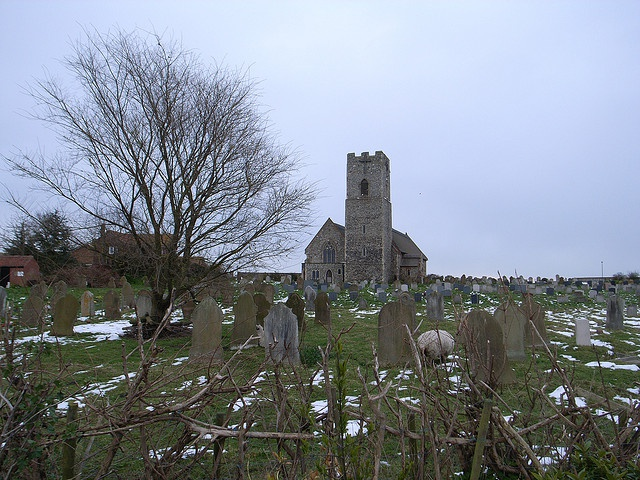Describe the objects in this image and their specific colors. I can see a sheep in lavender, gray, darkgray, and black tones in this image. 